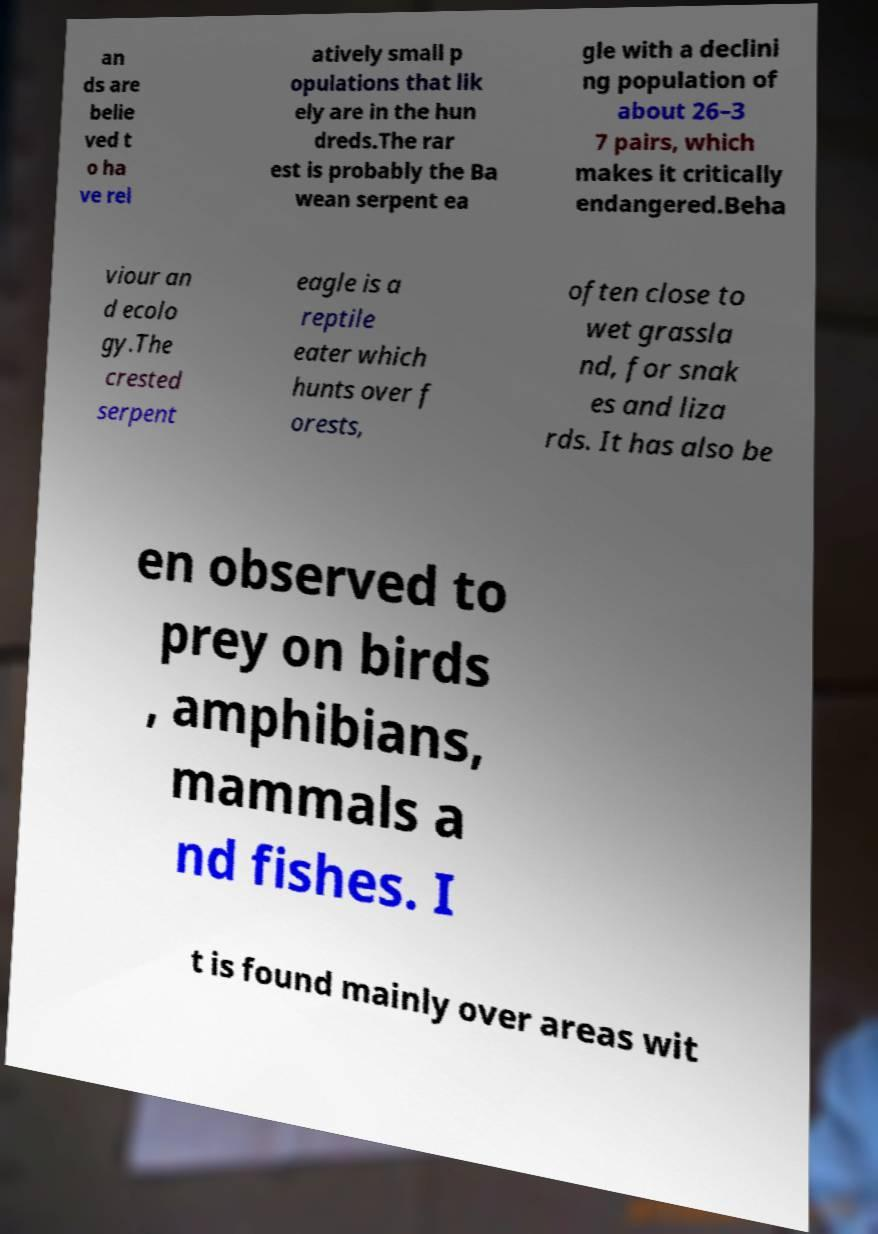There's text embedded in this image that I need extracted. Can you transcribe it verbatim? an ds are belie ved t o ha ve rel atively small p opulations that lik ely are in the hun dreds.The rar est is probably the Ba wean serpent ea gle with a declini ng population of about 26–3 7 pairs, which makes it critically endangered.Beha viour an d ecolo gy.The crested serpent eagle is a reptile eater which hunts over f orests, often close to wet grassla nd, for snak es and liza rds. It has also be en observed to prey on birds , amphibians, mammals a nd fishes. I t is found mainly over areas wit 